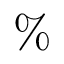Convert formula to latex. <formula><loc_0><loc_0><loc_500><loc_500>\%</formula> 